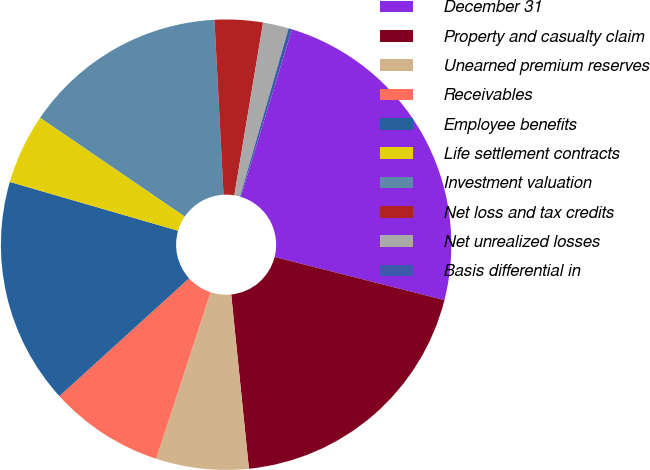Convert chart to OTSL. <chart><loc_0><loc_0><loc_500><loc_500><pie_chart><fcel>December 31<fcel>Property and casualty claim<fcel>Unearned premium reserves<fcel>Receivables<fcel>Employee benefits<fcel>Life settlement contracts<fcel>Investment valuation<fcel>Net loss and tax credits<fcel>Net unrealized losses<fcel>Basis differential in<nl><fcel>24.23%<fcel>19.43%<fcel>6.64%<fcel>8.24%<fcel>16.23%<fcel>5.04%<fcel>14.64%<fcel>3.45%<fcel>1.85%<fcel>0.25%<nl></chart> 